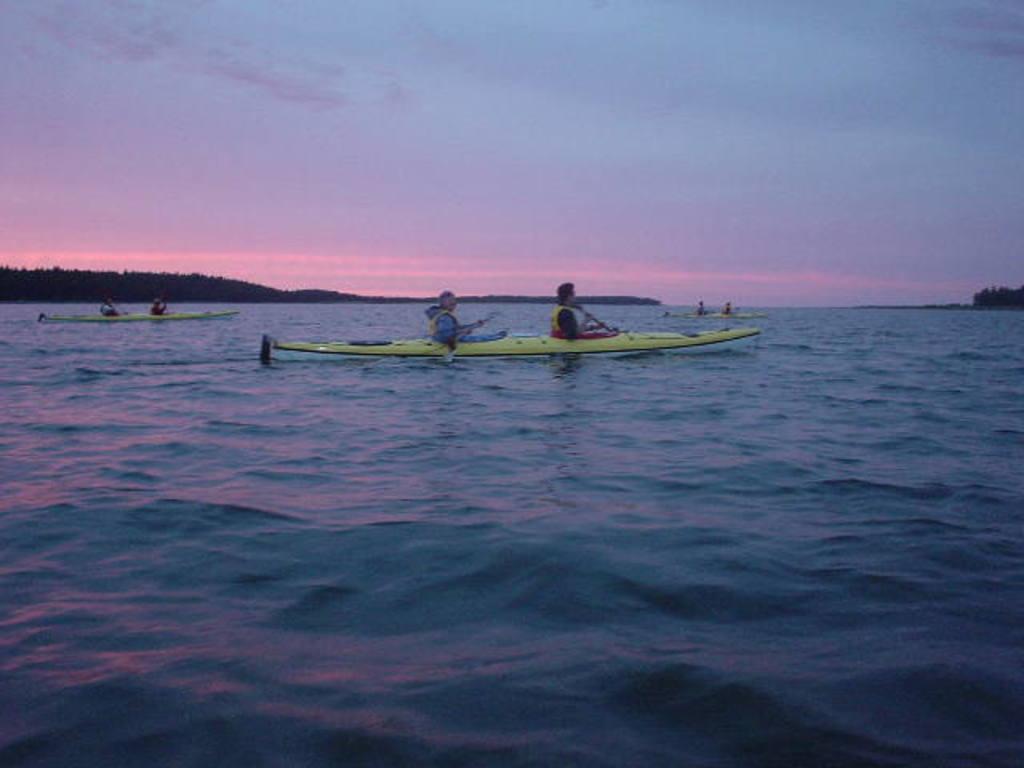How would you summarize this image in a sentence or two? In this picture I can see few boats in the water and few people are seated in the boats and I can see a cloudy sky. 